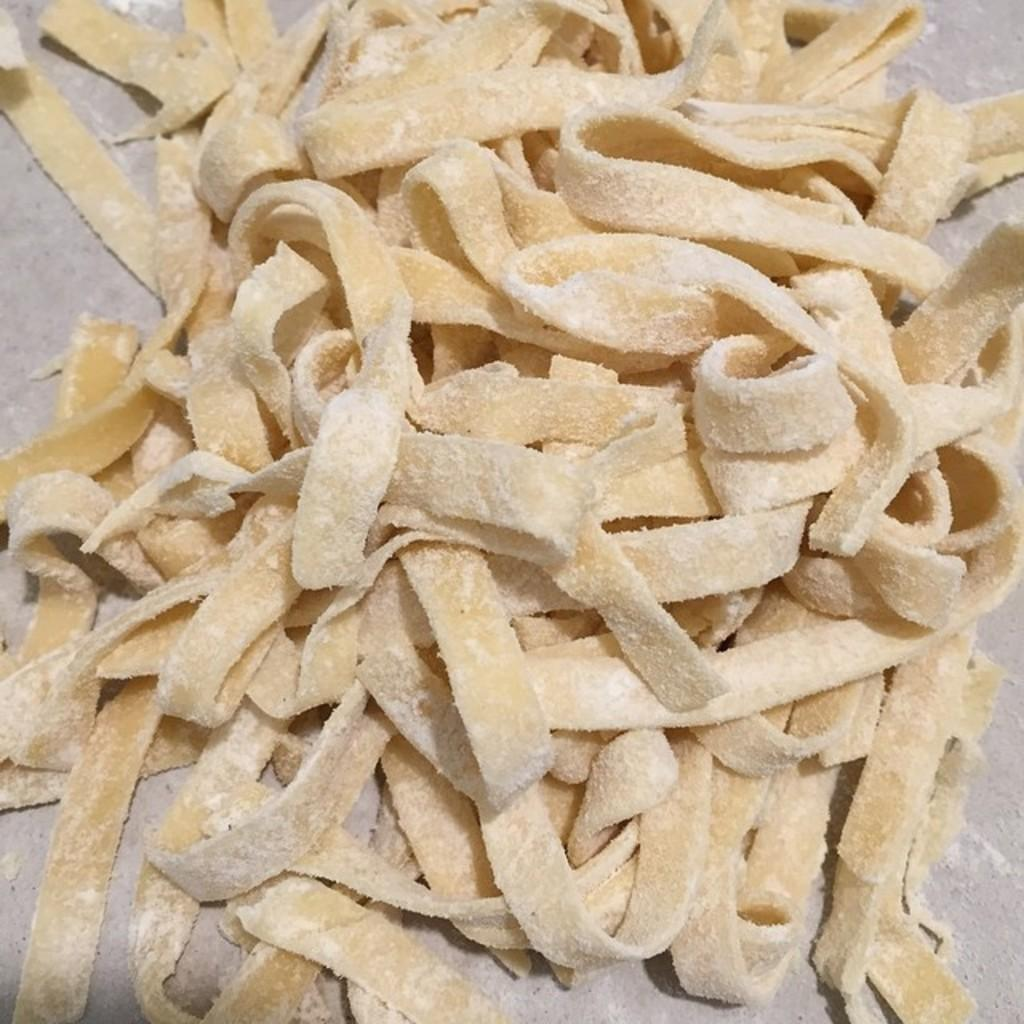What is present on the surface in the image? There is food on the surface in the image. Can you see any visible veins in the food on the surface? There is no indication of visible veins in the food on the surface in the image. 